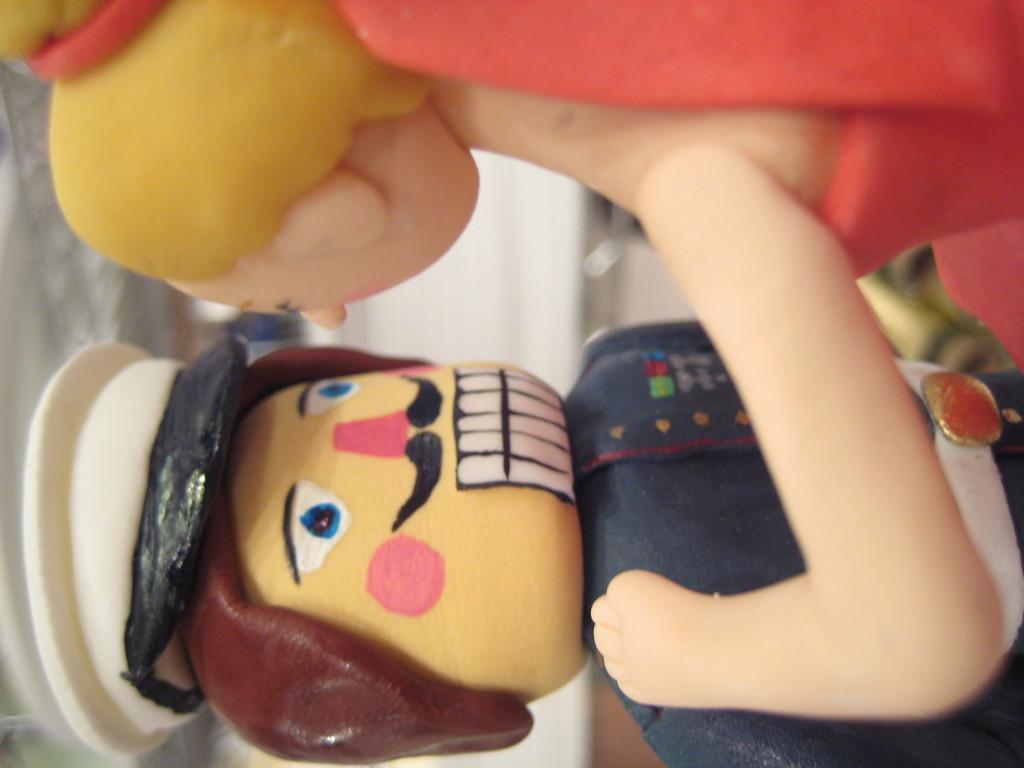Could you give a brief overview of what you see in this image? In the picture we can see two dolls and doll is keeping hand on the other doll and one doll is in police uniform. 